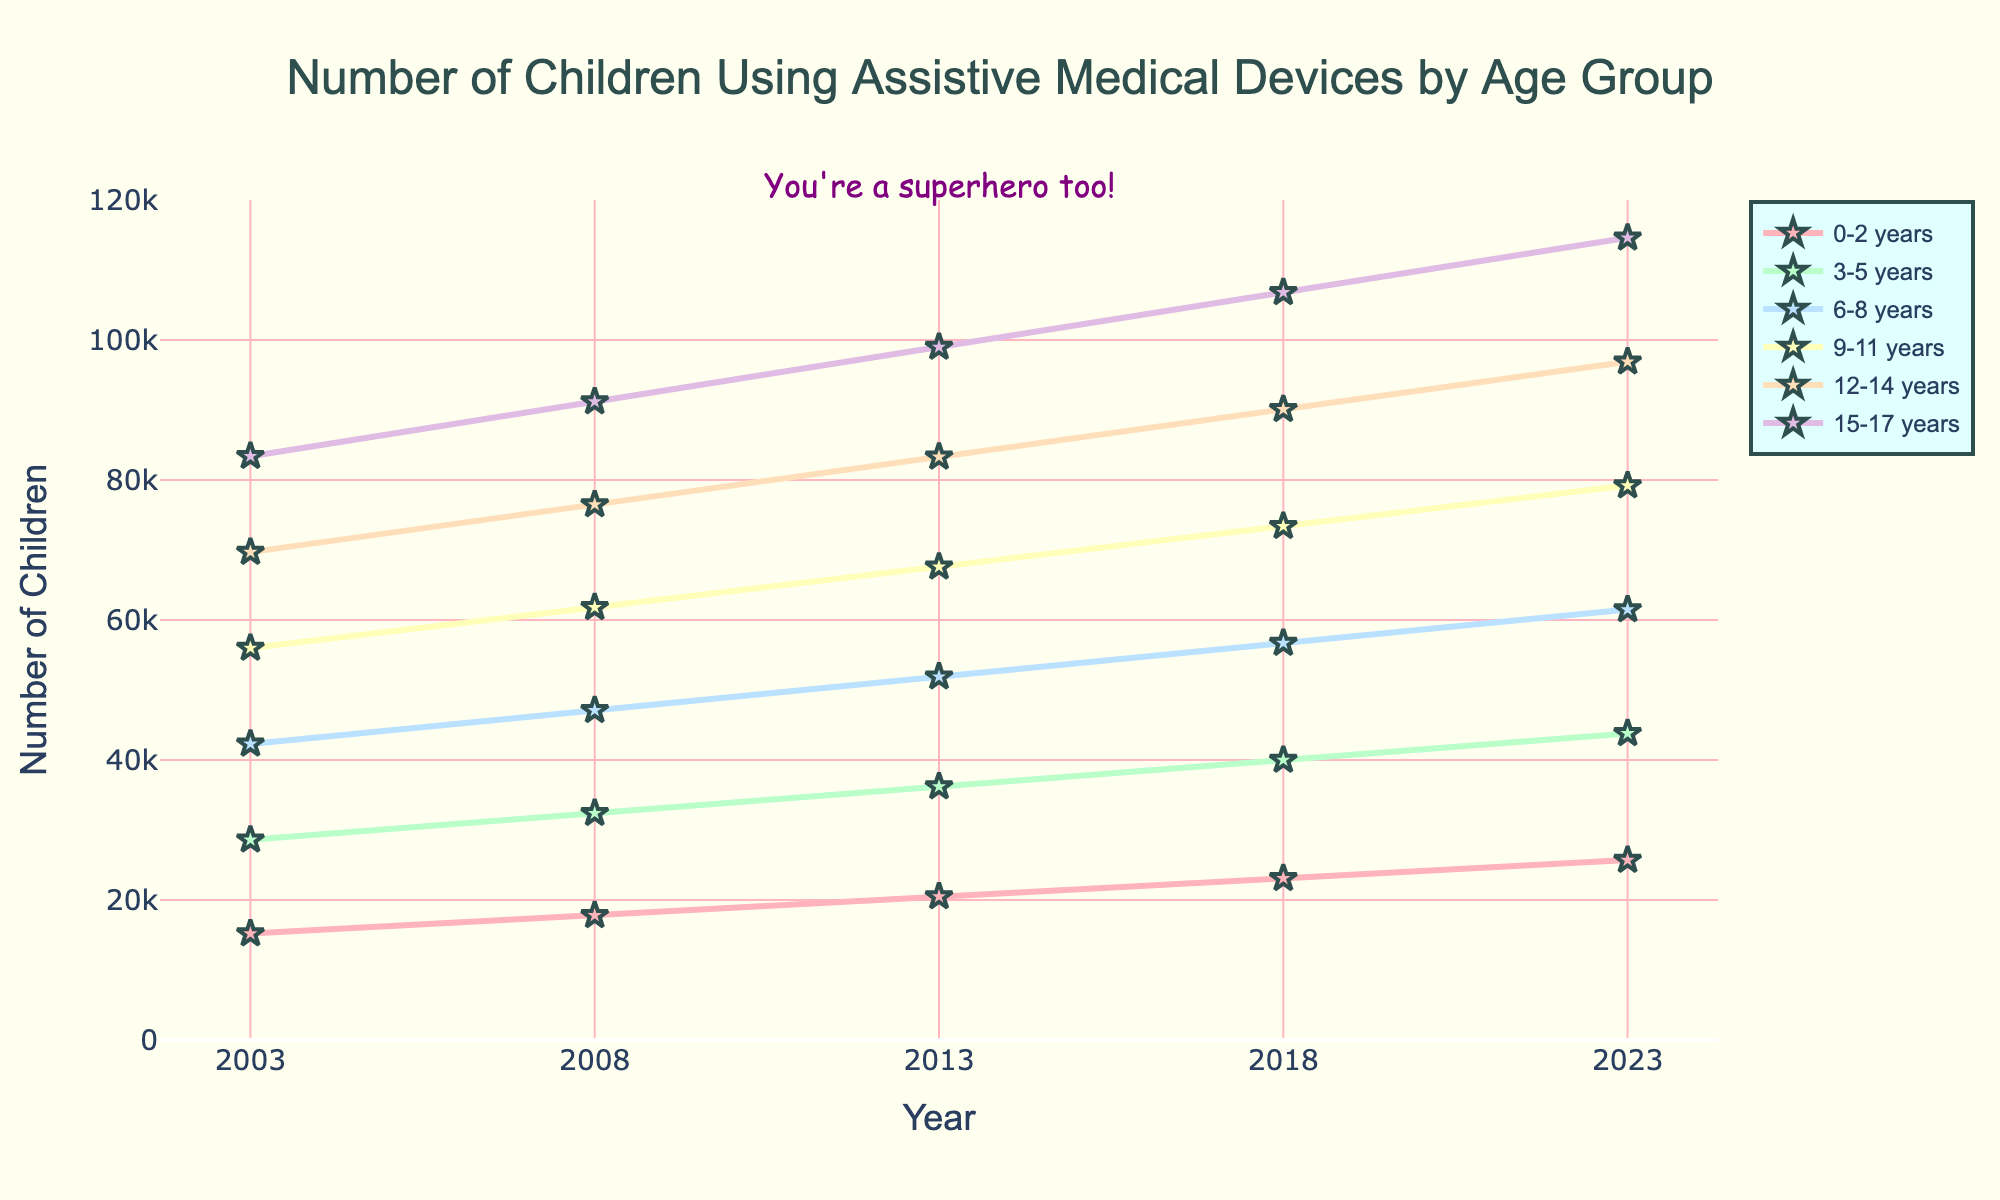what's the highest number of children using assistive medical devices for the 12-14 age group in the entire period? Look at the line corresponding to the 12-14 years age group and find the maximum value. The peak value for this group is in 2023, which is 96,900.
Answer: 96,900 which age group had the biggest increase from 2003 to 2023? Calculate the difference between the values in 2023 and 2003 for all age groups. For 0-2 years: 25,700 - 15,200 = 10,500; For 3-5 years: 43,800 - 28,600 = 15,200; For 6-8 years: 61,500 - 42,300 = 19,200; For 9-11 years: 79,200 - 56,000 = 23,200; For 12-14 years: 96,900 - 69,700 = 27,200; For 15-17 years: 114,600 - 83,400 = 31,200. The 15-17 years age group has the largest increase, which is 31,200.
Answer: 15-17 years what is the total number of children using assistive medical devices in 2018 for all age groups combined? Sum the values for all age groups in 2018. 23,100 (0-2 years) + 40,000 (3-5 years) + 56,700 (6-8 years) + 73,400 (9-11 years) + 90,100 (12-14 years) + 106,800 (15-17 years) = 389,100.
Answer: 389,100 what is the trend for the number of children in the 6-8 years age group from 2003 to 2023? Observe the line for the 6-8 years age group over the years. The number of children using assistive devices in this group steadily increases from 42,300 in 2003 to 61,500 in 2023.
Answer: Increasing which age group had the most significant increase between 2008 and 2013? Calculate the difference between 2013 and 2008 for each age group. 0-2 years: 20,500 - 17,800 = 2,700; 3-5 years: 36,200 - 32,400 = 3,800; 6-8 years: 51,900 - 47,100 = 4,800; 9-11 years: 67,600 - 61,800 = 5,800; 12-14 years: 83,300 - 76,500 = 6,800; 15-17 years: 99,000 - 91,200 = 7,800. The 15-17 years age group had the most significant increase, which is 7,800.
Answer: 15-17 years 